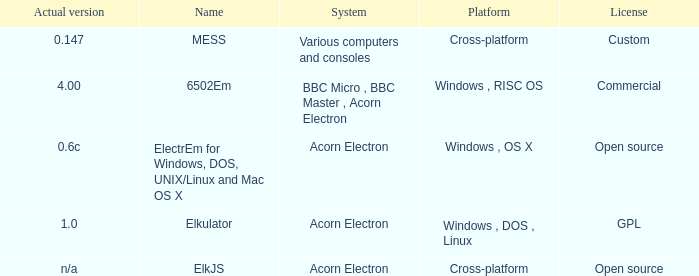What is the system called that is named ELKJS? Acorn Electron. 